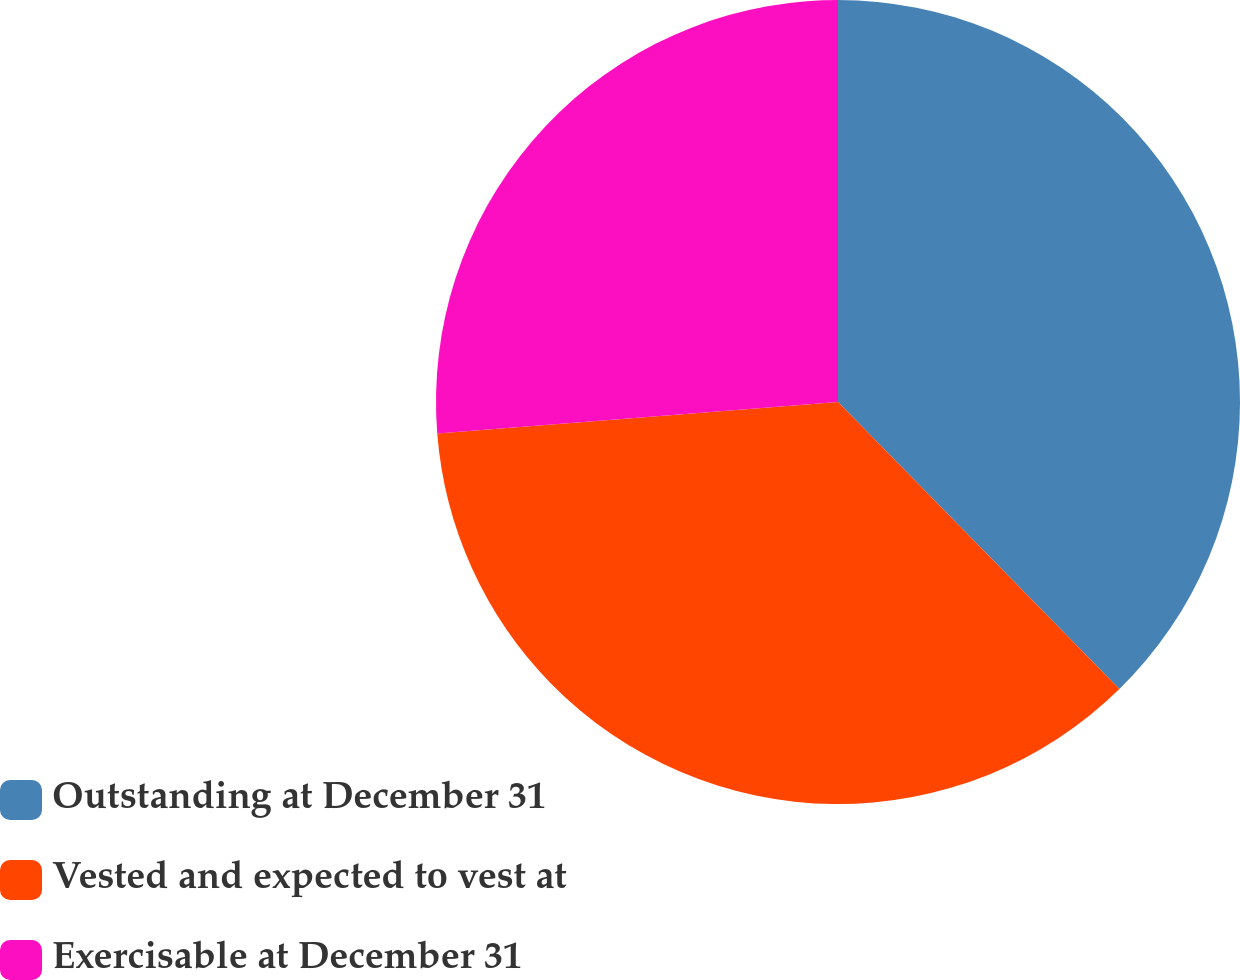<chart> <loc_0><loc_0><loc_500><loc_500><pie_chart><fcel>Outstanding at December 31<fcel>Vested and expected to vest at<fcel>Exercisable at December 31<nl><fcel>37.66%<fcel>36.09%<fcel>26.25%<nl></chart> 